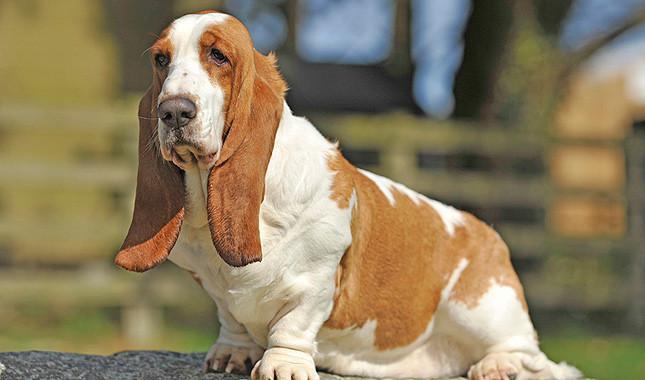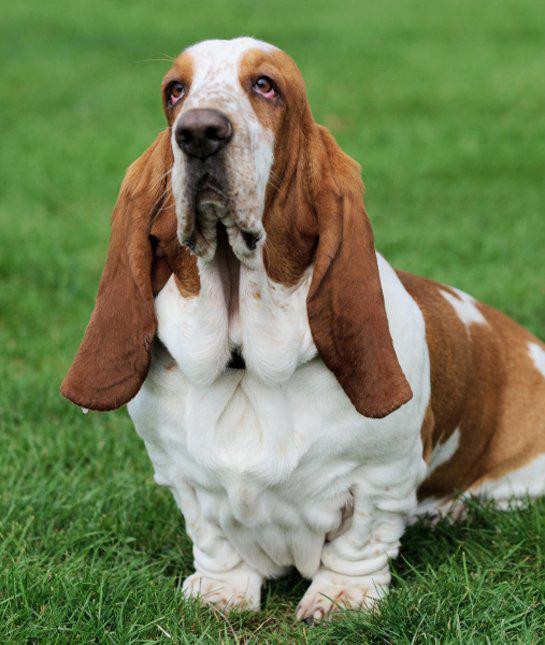The first image is the image on the left, the second image is the image on the right. For the images shown, is this caption "One of the dog has its chin on a surface." true? Answer yes or no. No. 